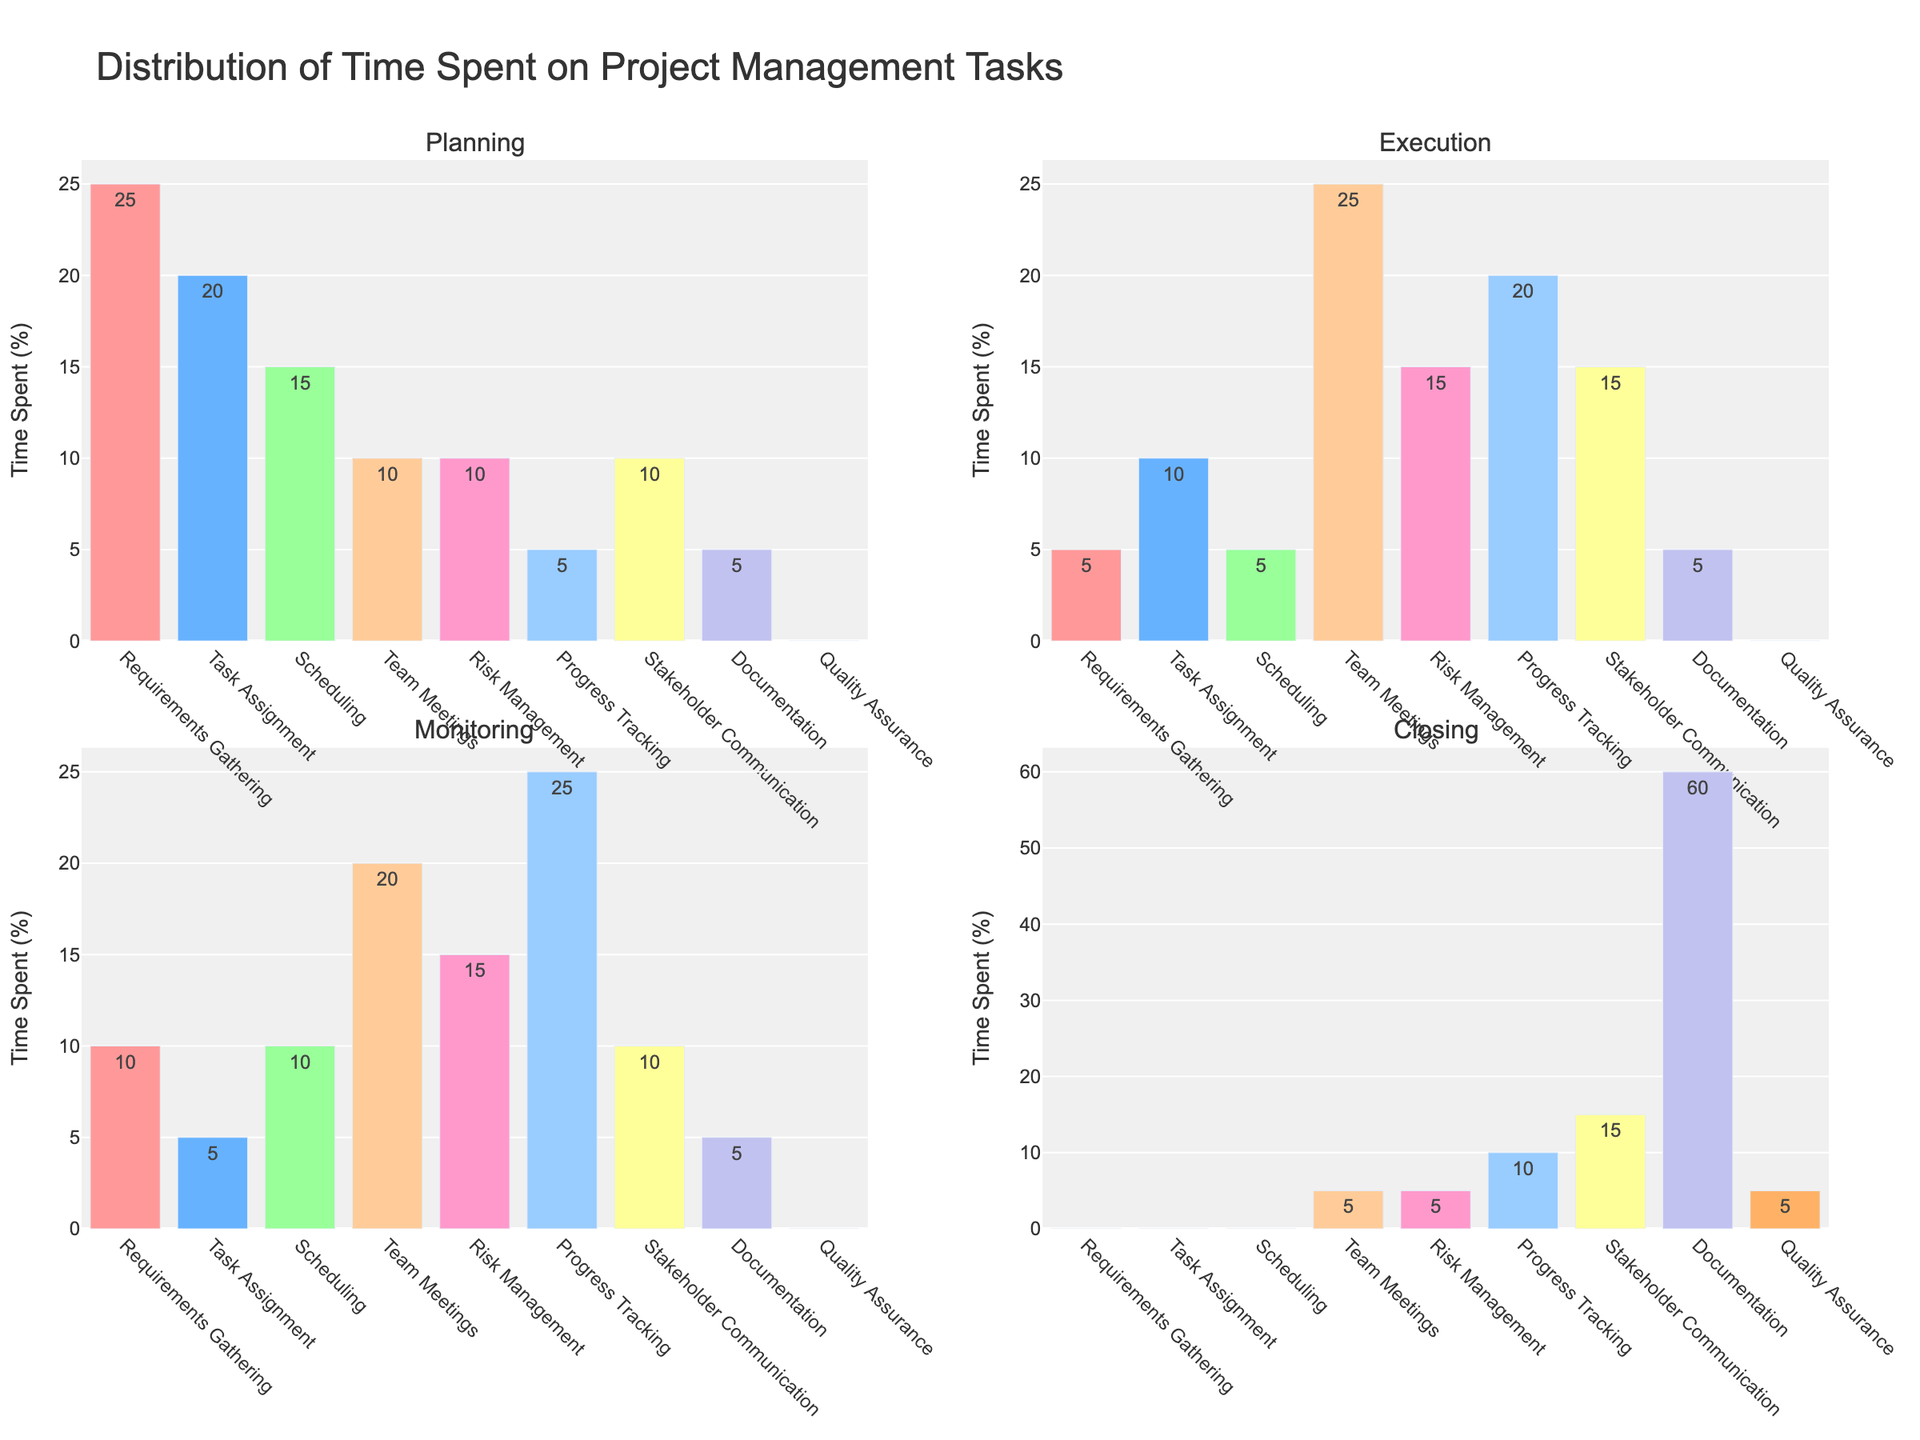What's the title of the figure? The title of the figure is typically located at the top center of the chart. By reading it directly, we can easily determine what the chart is about.
Answer: Distribution of Time Spent on Project Management Tasks What's the y-axis title for the subplots? Each subplot's y-axis title can be found by looking for the text next to the vertical axis in each subplot.
Answer: Time Spent (%) Which project phase has the highest time spent during the Planning phase? Look at the bar heights in the subplot titled "Planning" and find the tallest bar. The label corresponding to this bar indicates the project phase with the highest time spent.
Answer: Requirements Gathering How much time is spent on Stakeholder Communication during the Closing phase? In the subplot titled "Closing," find the bar corresponding to Stakeholder Communication and read the value next to it.
Answer: 15% What is the difference in time spent between Team Meetings and Documentation during the Execution phase? In the subplot titled "Execution," identify the bars for Team Meetings and Documentation. Note the values for each, then subtract the smaller value from the larger one to find the difference. Team Meetings (25%) - Documentation (5%) = 20%.
Answer: 20% Which task has the least time spent during the Monitoring phase? In the subplot titled "Monitoring," look for the shortest bar to determine the task with the least time spent.
Answer: Task Assignment and Documentation (both 5%) Compare the time spent on Risk Management during the Planning and Execution phases. Which phase has a higher value? Examine the bars for Risk Management in both the Planning and Execution subplots. The Planning phase bar shows 10%, and the Execution phase bar shows 15%. Execution is higher.
Answer: Execution What is the average time spent on Progress Tracking across all phases? Add up the time spent on Progress Tracking in each phase and then divide by the number of phases (4). (5 + 20 + 25 + 10) / 4 = 60 / 4 = 15%
Answer: 15% How much total time is spent on Documentation across all phases? Sum the time spent on Documentation in each phase: 5 + 5 + 5 + 60. The total is 75%.
Answer: 75% 